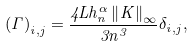<formula> <loc_0><loc_0><loc_500><loc_500>\left ( \Gamma \right ) _ { i , j } = \frac { 4 L h _ { n } ^ { \alpha } \left \| K \right \| _ { \infty } } { 3 n ^ { 3 } } \delta _ { i , j } ,</formula> 